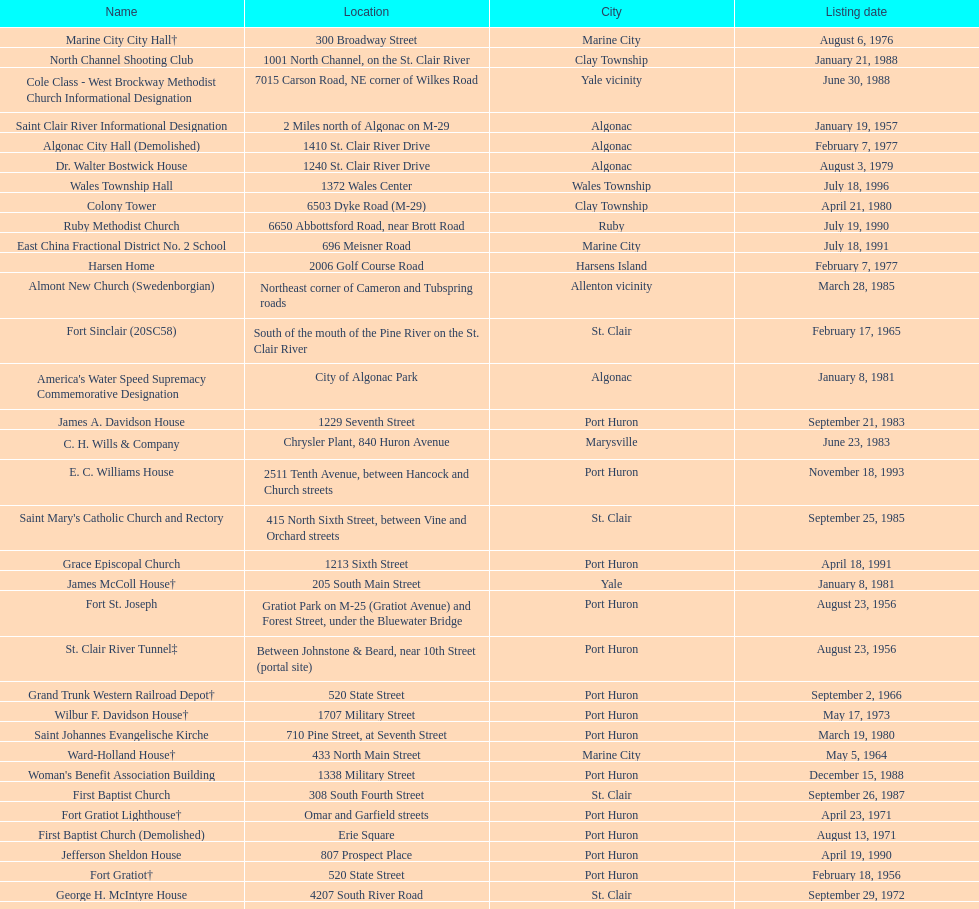Fort gratiot lighthouse and fort st. joseph are located in what city? Port Huron. 